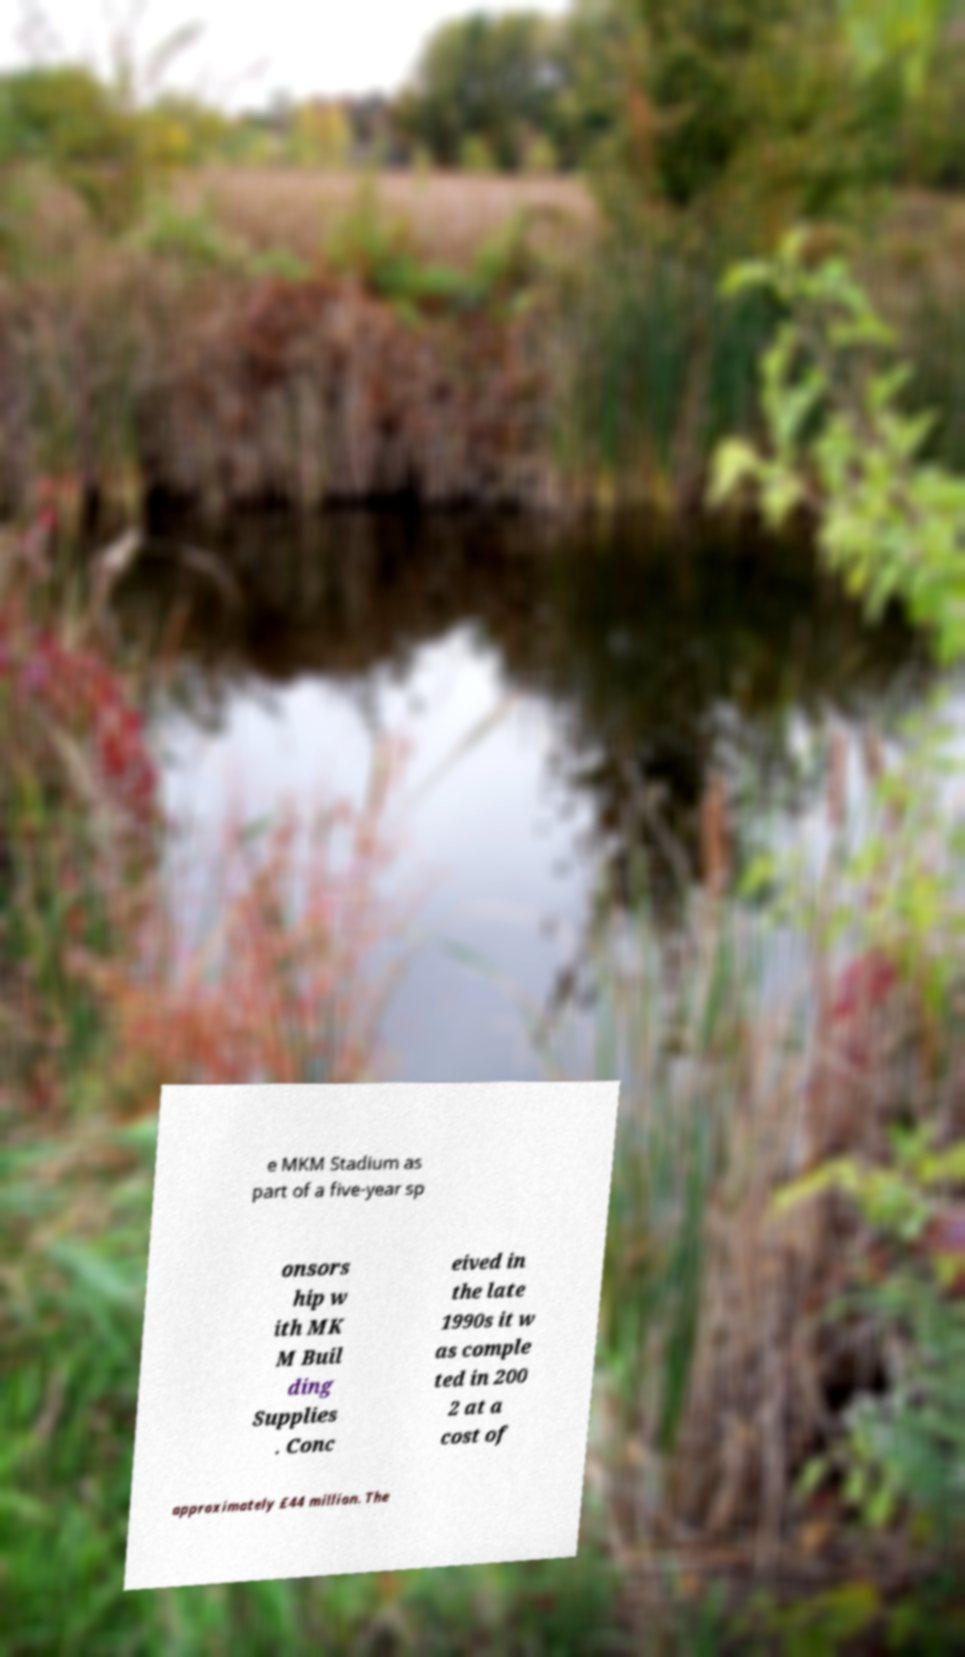Could you assist in decoding the text presented in this image and type it out clearly? e MKM Stadium as part of a five-year sp onsors hip w ith MK M Buil ding Supplies . Conc eived in the late 1990s it w as comple ted in 200 2 at a cost of approximately £44 million. The 